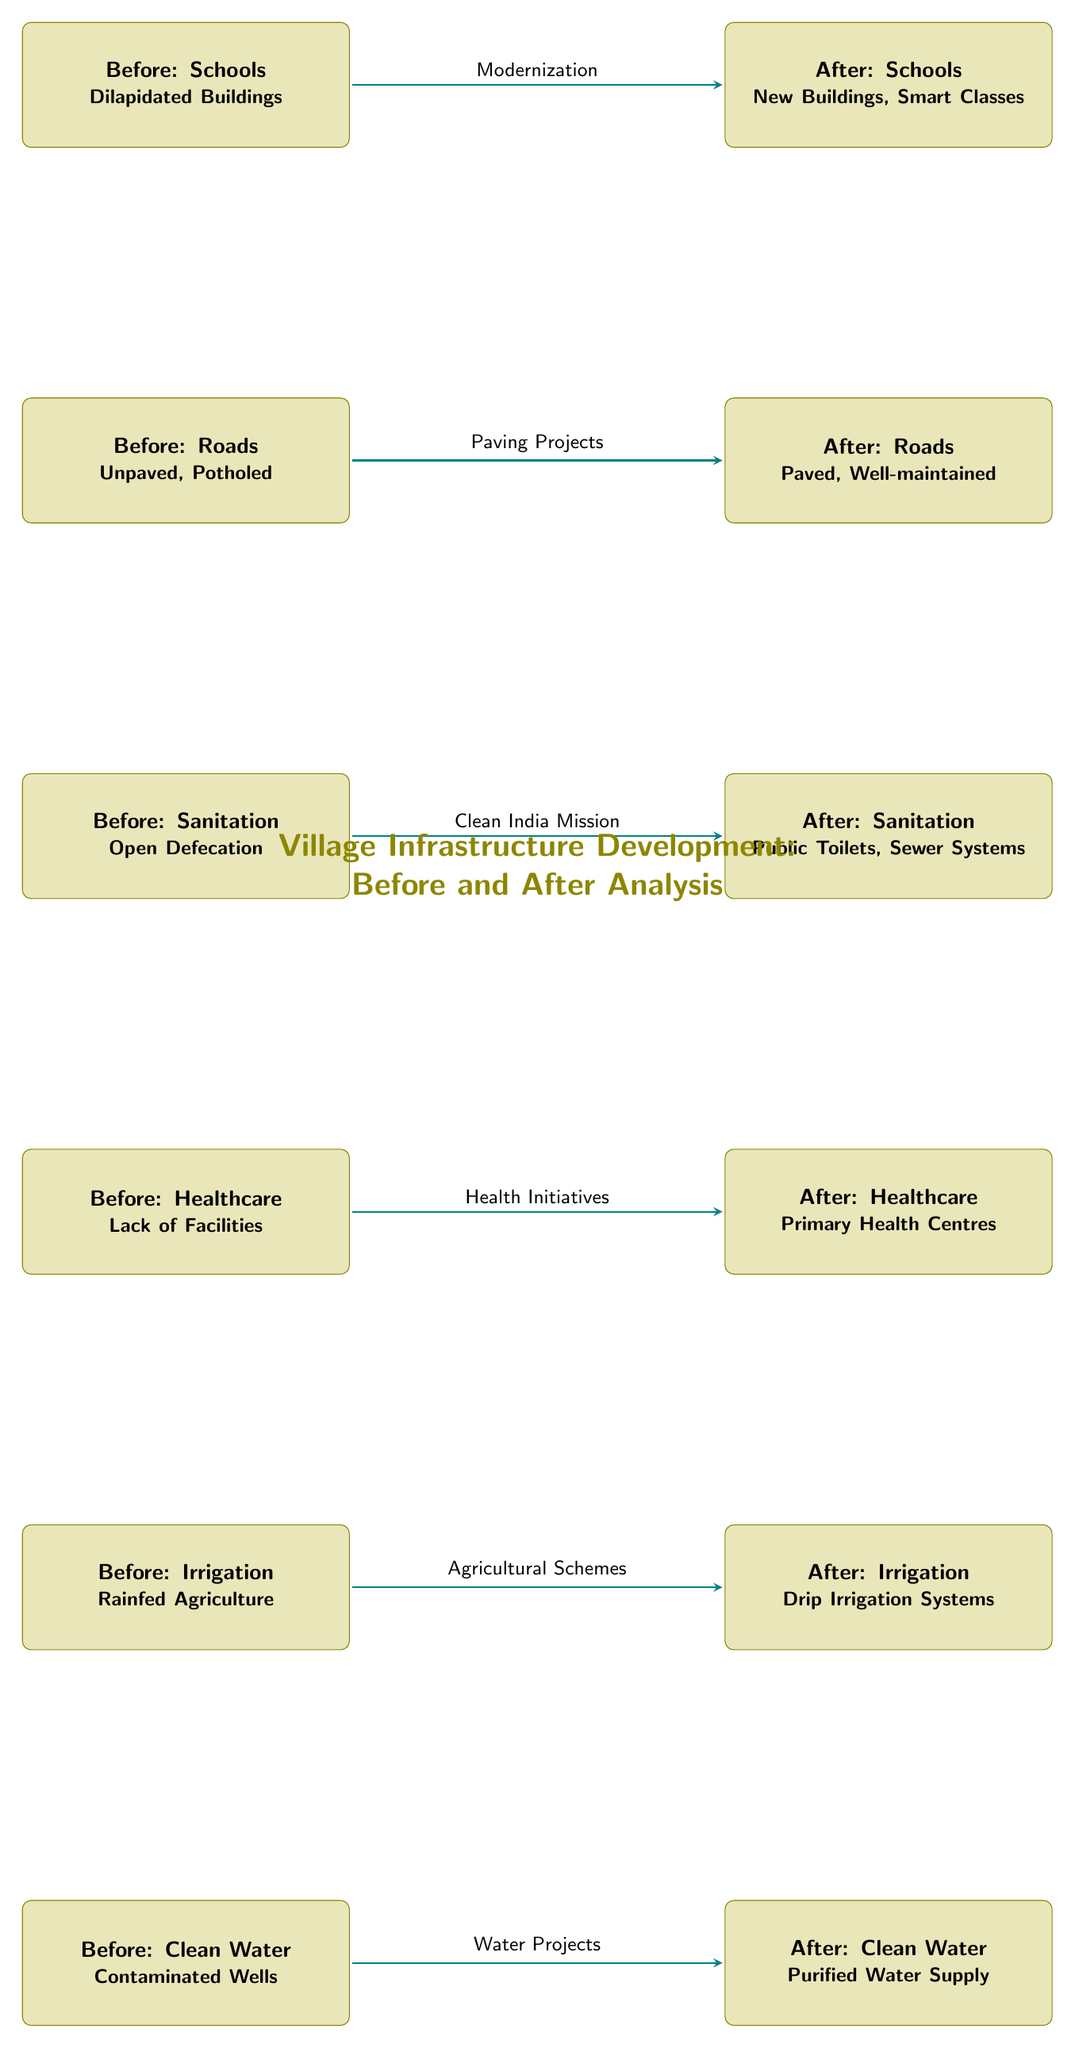What is the condition of schools before the development? The diagram indicates that the condition of schools before development is described as "Dilapidated Buildings." This is directly stated in the corresponding box on the left side of the diagram.
Answer: Dilapidated Buildings What improvement was made to the roads? The diagram shows that the roads transitioned from "Unpaved, Potholed" to "Paved, Well-maintained" after the development. This change is clearly labeled in the two boxes for roads in the diagram.
Answer: Paved, Well-maintained How many infrastructure categories are compared in the diagram? By counting the individual categories shown (Schools, Roads, Sanitation, Healthcare, Irrigation, and Clean Water), there are a total of six distinct infrastructure areas being compared.
Answer: 6 What initiative contributed to the improvement of sanitation? The arrow connecting the before and after scenarios for sanitation specifically indicates that the "Clean India Mission" was the driving force behind the transition from "Open Defecation" to "Public Toilets, Sewer Systems." This label is present on the arrow in the diagram.
Answer: Clean India Mission What type of irrigation was introduced after the development? According to the diagram, the type of irrigation that was introduced is described as "Drip Irrigation Systems," which is located in the box on the right side, indicating the improved condition.
Answer: Drip Irrigation Systems What is the relationship between healthcare before and after the development? The relationship is that before, there was a "Lack of Facilities," and after development, there are "Primary Health Centres." The arrow connecting these two states shows that healthcare was significantly enhanced.
Answer: Primary Health Centres Which sector saw a change from contaminated water to purified water? The raw data in the diagram shows that the Clean Water sector improved from "Contaminated Wells" to "Purified Water Supply," thus indicating a notable enhancement in water quality.
Answer: Purified Water Supply What was the primary focus of agricultural improvement indicated in the diagram? The diagram specifies that the agricultural improvement was achieved through "Agricultural Schemes," which indicates a systematic focus to develop irrigation for better agricultural practices.
Answer: Agricultural Schemes 